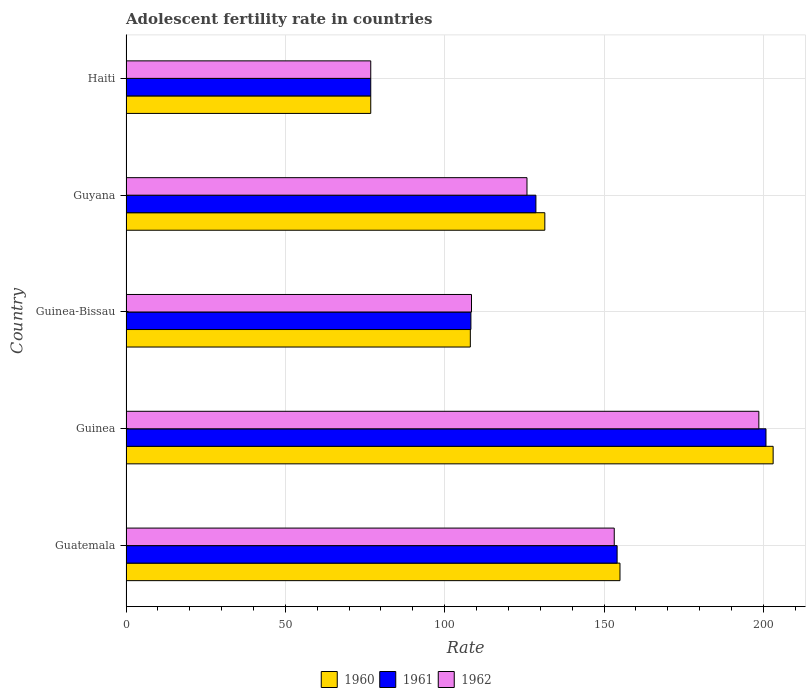How many groups of bars are there?
Ensure brevity in your answer.  5. How many bars are there on the 1st tick from the top?
Provide a short and direct response. 3. How many bars are there on the 2nd tick from the bottom?
Make the answer very short. 3. What is the label of the 5th group of bars from the top?
Offer a very short reply. Guatemala. In how many cases, is the number of bars for a given country not equal to the number of legend labels?
Your answer should be compact. 0. What is the adolescent fertility rate in 1960 in Guinea-Bissau?
Your answer should be very brief. 108.04. Across all countries, what is the maximum adolescent fertility rate in 1962?
Offer a very short reply. 198.58. Across all countries, what is the minimum adolescent fertility rate in 1960?
Make the answer very short. 76.8. In which country was the adolescent fertility rate in 1961 maximum?
Offer a very short reply. Guinea. In which country was the adolescent fertility rate in 1960 minimum?
Your response must be concise. Haiti. What is the total adolescent fertility rate in 1961 in the graph?
Offer a very short reply. 668.57. What is the difference between the adolescent fertility rate in 1961 in Guinea-Bissau and that in Haiti?
Offer a terse response. 31.43. What is the difference between the adolescent fertility rate in 1961 in Guyana and the adolescent fertility rate in 1962 in Guinea-Bissau?
Ensure brevity in your answer.  20.21. What is the average adolescent fertility rate in 1961 per country?
Give a very brief answer. 133.71. What is the ratio of the adolescent fertility rate in 1962 in Guatemala to that in Guyana?
Your answer should be very brief. 1.22. Is the adolescent fertility rate in 1960 in Guinea-Bissau less than that in Haiti?
Provide a succinct answer. No. Is the difference between the adolescent fertility rate in 1960 in Guinea and Guinea-Bissau greater than the difference between the adolescent fertility rate in 1961 in Guinea and Guinea-Bissau?
Keep it short and to the point. Yes. What is the difference between the highest and the second highest adolescent fertility rate in 1962?
Ensure brevity in your answer.  45.37. What is the difference between the highest and the lowest adolescent fertility rate in 1961?
Make the answer very short. 124.02. In how many countries, is the adolescent fertility rate in 1962 greater than the average adolescent fertility rate in 1962 taken over all countries?
Your answer should be compact. 2. Is the sum of the adolescent fertility rate in 1960 in Guinea and Haiti greater than the maximum adolescent fertility rate in 1961 across all countries?
Ensure brevity in your answer.  Yes. What does the 1st bar from the top in Guinea represents?
Offer a very short reply. 1962. What does the 1st bar from the bottom in Guatemala represents?
Offer a very short reply. 1960. Is it the case that in every country, the sum of the adolescent fertility rate in 1962 and adolescent fertility rate in 1960 is greater than the adolescent fertility rate in 1961?
Your answer should be very brief. Yes. Are all the bars in the graph horizontal?
Ensure brevity in your answer.  Yes. Are the values on the major ticks of X-axis written in scientific E-notation?
Offer a terse response. No. Does the graph contain grids?
Your answer should be very brief. Yes. Where does the legend appear in the graph?
Your response must be concise. Bottom center. How are the legend labels stacked?
Your answer should be compact. Horizontal. What is the title of the graph?
Offer a very short reply. Adolescent fertility rate in countries. What is the label or title of the X-axis?
Your response must be concise. Rate. What is the Rate of 1960 in Guatemala?
Offer a terse response. 155. What is the Rate in 1961 in Guatemala?
Provide a short and direct response. 154.1. What is the Rate in 1962 in Guatemala?
Offer a very short reply. 153.21. What is the Rate of 1960 in Guinea?
Your response must be concise. 203.06. What is the Rate of 1961 in Guinea?
Provide a succinct answer. 200.82. What is the Rate in 1962 in Guinea?
Offer a very short reply. 198.58. What is the Rate of 1960 in Guinea-Bissau?
Your answer should be compact. 108.04. What is the Rate of 1961 in Guinea-Bissau?
Your answer should be compact. 108.23. What is the Rate in 1962 in Guinea-Bissau?
Your answer should be compact. 108.41. What is the Rate in 1960 in Guyana?
Make the answer very short. 131.42. What is the Rate in 1961 in Guyana?
Offer a very short reply. 128.62. What is the Rate of 1962 in Guyana?
Your answer should be very brief. 125.82. What is the Rate of 1960 in Haiti?
Ensure brevity in your answer.  76.8. What is the Rate in 1961 in Haiti?
Keep it short and to the point. 76.8. What is the Rate of 1962 in Haiti?
Provide a short and direct response. 76.8. Across all countries, what is the maximum Rate in 1960?
Offer a very short reply. 203.06. Across all countries, what is the maximum Rate of 1961?
Give a very brief answer. 200.82. Across all countries, what is the maximum Rate in 1962?
Offer a terse response. 198.58. Across all countries, what is the minimum Rate of 1960?
Make the answer very short. 76.8. Across all countries, what is the minimum Rate of 1961?
Offer a very short reply. 76.8. Across all countries, what is the minimum Rate in 1962?
Provide a succinct answer. 76.8. What is the total Rate in 1960 in the graph?
Offer a very short reply. 674.33. What is the total Rate in 1961 in the graph?
Provide a short and direct response. 668.57. What is the total Rate of 1962 in the graph?
Your response must be concise. 662.81. What is the difference between the Rate in 1960 in Guatemala and that in Guinea?
Your answer should be very brief. -48.06. What is the difference between the Rate of 1961 in Guatemala and that in Guinea?
Make the answer very short. -46.72. What is the difference between the Rate of 1962 in Guatemala and that in Guinea?
Provide a short and direct response. -45.37. What is the difference between the Rate in 1960 in Guatemala and that in Guinea-Bissau?
Ensure brevity in your answer.  46.96. What is the difference between the Rate of 1961 in Guatemala and that in Guinea-Bissau?
Ensure brevity in your answer.  45.88. What is the difference between the Rate of 1962 in Guatemala and that in Guinea-Bissau?
Your response must be concise. 44.8. What is the difference between the Rate in 1960 in Guatemala and that in Guyana?
Ensure brevity in your answer.  23.58. What is the difference between the Rate of 1961 in Guatemala and that in Guyana?
Offer a terse response. 25.48. What is the difference between the Rate of 1962 in Guatemala and that in Guyana?
Offer a terse response. 27.38. What is the difference between the Rate in 1960 in Guatemala and that in Haiti?
Offer a terse response. 78.21. What is the difference between the Rate of 1961 in Guatemala and that in Haiti?
Ensure brevity in your answer.  77.31. What is the difference between the Rate of 1962 in Guatemala and that in Haiti?
Make the answer very short. 76.41. What is the difference between the Rate of 1960 in Guinea and that in Guinea-Bissau?
Keep it short and to the point. 95.02. What is the difference between the Rate in 1961 in Guinea and that in Guinea-Bissau?
Your answer should be very brief. 92.59. What is the difference between the Rate in 1962 in Guinea and that in Guinea-Bissau?
Your answer should be very brief. 90.17. What is the difference between the Rate of 1960 in Guinea and that in Guyana?
Offer a very short reply. 71.64. What is the difference between the Rate of 1961 in Guinea and that in Guyana?
Ensure brevity in your answer.  72.2. What is the difference between the Rate in 1962 in Guinea and that in Guyana?
Provide a succinct answer. 72.75. What is the difference between the Rate of 1960 in Guinea and that in Haiti?
Make the answer very short. 126.26. What is the difference between the Rate of 1961 in Guinea and that in Haiti?
Provide a succinct answer. 124.02. What is the difference between the Rate in 1962 in Guinea and that in Haiti?
Your response must be concise. 121.78. What is the difference between the Rate of 1960 in Guinea-Bissau and that in Guyana?
Provide a short and direct response. -23.37. What is the difference between the Rate of 1961 in Guinea-Bissau and that in Guyana?
Ensure brevity in your answer.  -20.39. What is the difference between the Rate in 1962 in Guinea-Bissau and that in Guyana?
Keep it short and to the point. -17.41. What is the difference between the Rate in 1960 in Guinea-Bissau and that in Haiti?
Provide a short and direct response. 31.25. What is the difference between the Rate of 1961 in Guinea-Bissau and that in Haiti?
Keep it short and to the point. 31.43. What is the difference between the Rate in 1962 in Guinea-Bissau and that in Haiti?
Provide a short and direct response. 31.61. What is the difference between the Rate of 1960 in Guyana and that in Haiti?
Keep it short and to the point. 54.62. What is the difference between the Rate in 1961 in Guyana and that in Haiti?
Provide a succinct answer. 51.82. What is the difference between the Rate in 1962 in Guyana and that in Haiti?
Keep it short and to the point. 49.02. What is the difference between the Rate of 1960 in Guatemala and the Rate of 1961 in Guinea?
Your answer should be very brief. -45.82. What is the difference between the Rate of 1960 in Guatemala and the Rate of 1962 in Guinea?
Your answer should be compact. -43.57. What is the difference between the Rate in 1961 in Guatemala and the Rate in 1962 in Guinea?
Your answer should be very brief. -44.47. What is the difference between the Rate of 1960 in Guatemala and the Rate of 1961 in Guinea-Bissau?
Provide a succinct answer. 46.78. What is the difference between the Rate of 1960 in Guatemala and the Rate of 1962 in Guinea-Bissau?
Offer a very short reply. 46.59. What is the difference between the Rate in 1961 in Guatemala and the Rate in 1962 in Guinea-Bissau?
Your answer should be compact. 45.7. What is the difference between the Rate of 1960 in Guatemala and the Rate of 1961 in Guyana?
Provide a succinct answer. 26.38. What is the difference between the Rate in 1960 in Guatemala and the Rate in 1962 in Guyana?
Your response must be concise. 29.18. What is the difference between the Rate of 1961 in Guatemala and the Rate of 1962 in Guyana?
Provide a short and direct response. 28.28. What is the difference between the Rate of 1960 in Guatemala and the Rate of 1961 in Haiti?
Ensure brevity in your answer.  78.21. What is the difference between the Rate of 1960 in Guatemala and the Rate of 1962 in Haiti?
Keep it short and to the point. 78.21. What is the difference between the Rate of 1961 in Guatemala and the Rate of 1962 in Haiti?
Offer a terse response. 77.31. What is the difference between the Rate of 1960 in Guinea and the Rate of 1961 in Guinea-Bissau?
Make the answer very short. 94.84. What is the difference between the Rate of 1960 in Guinea and the Rate of 1962 in Guinea-Bissau?
Provide a succinct answer. 94.65. What is the difference between the Rate in 1961 in Guinea and the Rate in 1962 in Guinea-Bissau?
Provide a succinct answer. 92.41. What is the difference between the Rate in 1960 in Guinea and the Rate in 1961 in Guyana?
Ensure brevity in your answer.  74.44. What is the difference between the Rate in 1960 in Guinea and the Rate in 1962 in Guyana?
Make the answer very short. 77.24. What is the difference between the Rate of 1961 in Guinea and the Rate of 1962 in Guyana?
Provide a short and direct response. 75. What is the difference between the Rate in 1960 in Guinea and the Rate in 1961 in Haiti?
Give a very brief answer. 126.26. What is the difference between the Rate in 1960 in Guinea and the Rate in 1962 in Haiti?
Your answer should be very brief. 126.26. What is the difference between the Rate of 1961 in Guinea and the Rate of 1962 in Haiti?
Your answer should be very brief. 124.02. What is the difference between the Rate in 1960 in Guinea-Bissau and the Rate in 1961 in Guyana?
Give a very brief answer. -20.58. What is the difference between the Rate of 1960 in Guinea-Bissau and the Rate of 1962 in Guyana?
Keep it short and to the point. -17.78. What is the difference between the Rate in 1961 in Guinea-Bissau and the Rate in 1962 in Guyana?
Make the answer very short. -17.6. What is the difference between the Rate of 1960 in Guinea-Bissau and the Rate of 1961 in Haiti?
Keep it short and to the point. 31.25. What is the difference between the Rate of 1960 in Guinea-Bissau and the Rate of 1962 in Haiti?
Provide a succinct answer. 31.25. What is the difference between the Rate in 1961 in Guinea-Bissau and the Rate in 1962 in Haiti?
Your answer should be compact. 31.43. What is the difference between the Rate in 1960 in Guyana and the Rate in 1961 in Haiti?
Make the answer very short. 54.62. What is the difference between the Rate of 1960 in Guyana and the Rate of 1962 in Haiti?
Provide a succinct answer. 54.62. What is the difference between the Rate of 1961 in Guyana and the Rate of 1962 in Haiti?
Ensure brevity in your answer.  51.82. What is the average Rate of 1960 per country?
Provide a succinct answer. 134.87. What is the average Rate in 1961 per country?
Keep it short and to the point. 133.71. What is the average Rate of 1962 per country?
Offer a terse response. 132.56. What is the difference between the Rate in 1960 and Rate in 1961 in Guatemala?
Give a very brief answer. 0.9. What is the difference between the Rate in 1960 and Rate in 1962 in Guatemala?
Offer a very short reply. 1.8. What is the difference between the Rate of 1961 and Rate of 1962 in Guatemala?
Ensure brevity in your answer.  0.9. What is the difference between the Rate in 1960 and Rate in 1961 in Guinea?
Your response must be concise. 2.24. What is the difference between the Rate in 1960 and Rate in 1962 in Guinea?
Your answer should be very brief. 4.48. What is the difference between the Rate of 1961 and Rate of 1962 in Guinea?
Offer a terse response. 2.24. What is the difference between the Rate in 1960 and Rate in 1961 in Guinea-Bissau?
Keep it short and to the point. -0.18. What is the difference between the Rate of 1960 and Rate of 1962 in Guinea-Bissau?
Keep it short and to the point. -0.36. What is the difference between the Rate of 1961 and Rate of 1962 in Guinea-Bissau?
Offer a very short reply. -0.18. What is the difference between the Rate of 1960 and Rate of 1961 in Guyana?
Provide a short and direct response. 2.8. What is the difference between the Rate of 1960 and Rate of 1962 in Guyana?
Keep it short and to the point. 5.6. What is the difference between the Rate of 1961 and Rate of 1962 in Guyana?
Give a very brief answer. 2.8. What is the difference between the Rate in 1960 and Rate in 1961 in Haiti?
Offer a very short reply. 0. What is the difference between the Rate in 1960 and Rate in 1962 in Haiti?
Provide a short and direct response. 0. What is the ratio of the Rate in 1960 in Guatemala to that in Guinea?
Offer a terse response. 0.76. What is the ratio of the Rate of 1961 in Guatemala to that in Guinea?
Your answer should be very brief. 0.77. What is the ratio of the Rate in 1962 in Guatemala to that in Guinea?
Offer a very short reply. 0.77. What is the ratio of the Rate in 1960 in Guatemala to that in Guinea-Bissau?
Give a very brief answer. 1.43. What is the ratio of the Rate of 1961 in Guatemala to that in Guinea-Bissau?
Ensure brevity in your answer.  1.42. What is the ratio of the Rate in 1962 in Guatemala to that in Guinea-Bissau?
Make the answer very short. 1.41. What is the ratio of the Rate of 1960 in Guatemala to that in Guyana?
Offer a terse response. 1.18. What is the ratio of the Rate of 1961 in Guatemala to that in Guyana?
Give a very brief answer. 1.2. What is the ratio of the Rate of 1962 in Guatemala to that in Guyana?
Offer a terse response. 1.22. What is the ratio of the Rate in 1960 in Guatemala to that in Haiti?
Offer a very short reply. 2.02. What is the ratio of the Rate of 1961 in Guatemala to that in Haiti?
Provide a short and direct response. 2.01. What is the ratio of the Rate of 1962 in Guatemala to that in Haiti?
Provide a short and direct response. 1.99. What is the ratio of the Rate in 1960 in Guinea to that in Guinea-Bissau?
Offer a terse response. 1.88. What is the ratio of the Rate of 1961 in Guinea to that in Guinea-Bissau?
Your response must be concise. 1.86. What is the ratio of the Rate of 1962 in Guinea to that in Guinea-Bissau?
Your answer should be very brief. 1.83. What is the ratio of the Rate in 1960 in Guinea to that in Guyana?
Offer a terse response. 1.55. What is the ratio of the Rate in 1961 in Guinea to that in Guyana?
Ensure brevity in your answer.  1.56. What is the ratio of the Rate of 1962 in Guinea to that in Guyana?
Your answer should be compact. 1.58. What is the ratio of the Rate of 1960 in Guinea to that in Haiti?
Provide a succinct answer. 2.64. What is the ratio of the Rate in 1961 in Guinea to that in Haiti?
Offer a very short reply. 2.61. What is the ratio of the Rate in 1962 in Guinea to that in Haiti?
Make the answer very short. 2.59. What is the ratio of the Rate of 1960 in Guinea-Bissau to that in Guyana?
Offer a terse response. 0.82. What is the ratio of the Rate of 1961 in Guinea-Bissau to that in Guyana?
Offer a very short reply. 0.84. What is the ratio of the Rate of 1962 in Guinea-Bissau to that in Guyana?
Keep it short and to the point. 0.86. What is the ratio of the Rate of 1960 in Guinea-Bissau to that in Haiti?
Offer a very short reply. 1.41. What is the ratio of the Rate of 1961 in Guinea-Bissau to that in Haiti?
Your answer should be very brief. 1.41. What is the ratio of the Rate in 1962 in Guinea-Bissau to that in Haiti?
Ensure brevity in your answer.  1.41. What is the ratio of the Rate of 1960 in Guyana to that in Haiti?
Your response must be concise. 1.71. What is the ratio of the Rate of 1961 in Guyana to that in Haiti?
Your answer should be compact. 1.67. What is the ratio of the Rate of 1962 in Guyana to that in Haiti?
Give a very brief answer. 1.64. What is the difference between the highest and the second highest Rate in 1960?
Offer a terse response. 48.06. What is the difference between the highest and the second highest Rate of 1961?
Ensure brevity in your answer.  46.72. What is the difference between the highest and the second highest Rate of 1962?
Offer a very short reply. 45.37. What is the difference between the highest and the lowest Rate of 1960?
Provide a short and direct response. 126.26. What is the difference between the highest and the lowest Rate of 1961?
Offer a very short reply. 124.02. What is the difference between the highest and the lowest Rate in 1962?
Keep it short and to the point. 121.78. 